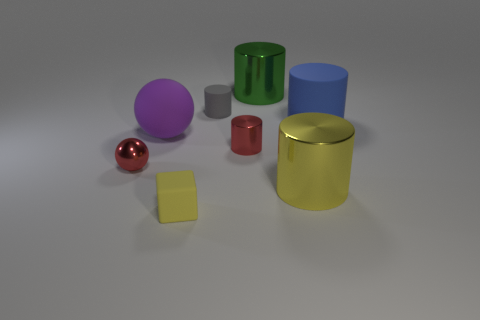What number of things are either tiny things that are behind the tiny yellow rubber object or purple matte spheres left of the red metallic cylinder?
Provide a short and direct response. 4. There is a rubber cylinder that is behind the big rubber cylinder; is its size the same as the red metallic object that is to the left of the tiny yellow block?
Your answer should be compact. Yes. The large rubber thing that is the same shape as the large green metal object is what color?
Your answer should be very brief. Blue. Are there any other things that are the same shape as the yellow rubber thing?
Keep it short and to the point. No. Is the number of large rubber things to the left of the red cylinder greater than the number of red shiny cylinders left of the big matte sphere?
Offer a very short reply. Yes. What is the size of the yellow object that is on the right side of the yellow object in front of the cylinder that is in front of the small sphere?
Give a very brief answer. Large. Does the gray thing have the same material as the red thing that is on the right side of the cube?
Your response must be concise. No. Does the tiny yellow matte object have the same shape as the tiny gray rubber object?
Your answer should be very brief. No. How many other things are the same material as the tiny block?
Your answer should be very brief. 3. How many small brown metallic objects have the same shape as the purple matte object?
Make the answer very short. 0. 